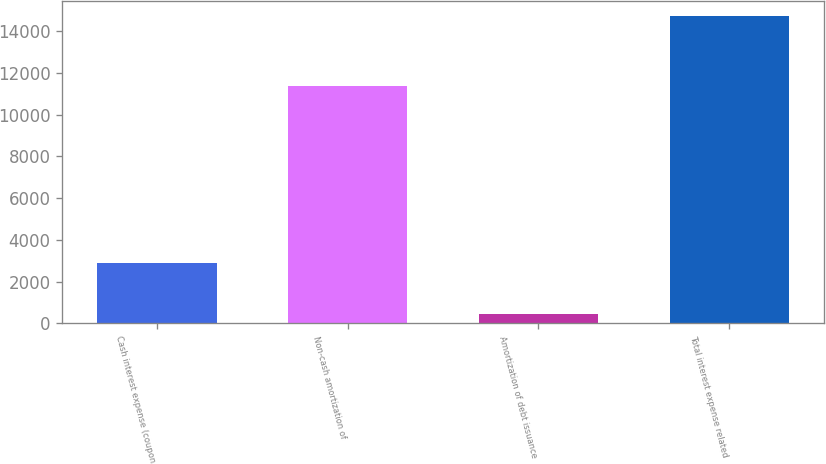Convert chart. <chart><loc_0><loc_0><loc_500><loc_500><bar_chart><fcel>Cash interest expense (coupon<fcel>Non-cash amortization of<fcel>Amortization of debt issuance<fcel>Total interest expense related<nl><fcel>2875<fcel>11387<fcel>466<fcel>14728<nl></chart> 